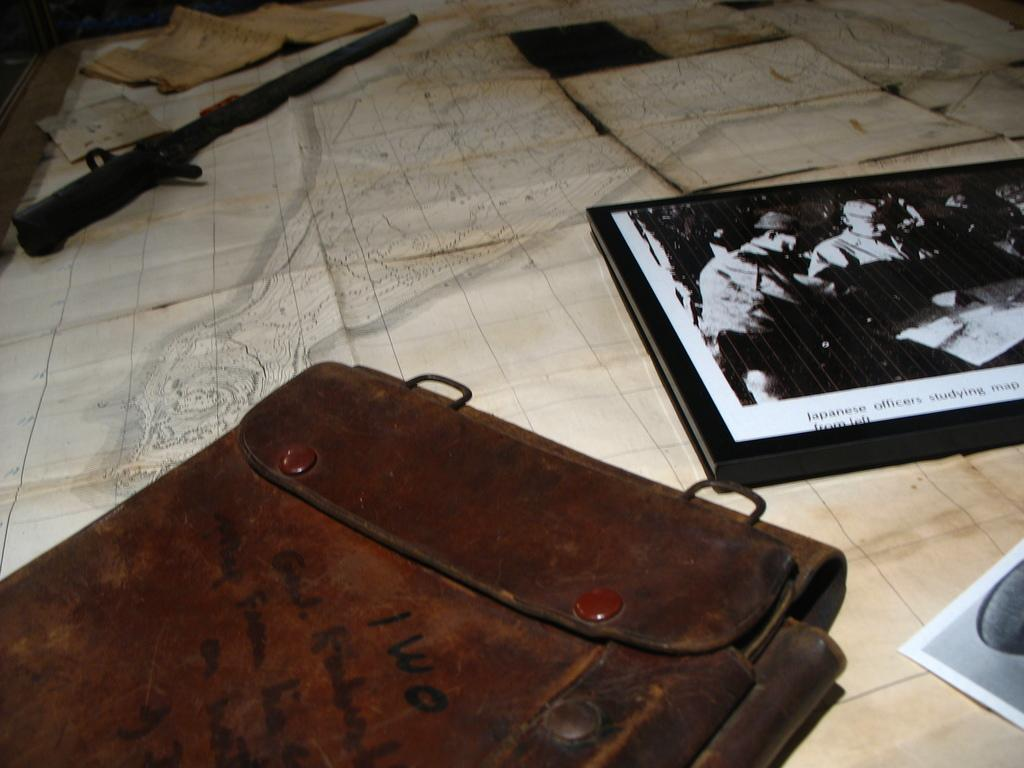What type of object can be seen in the image that might be used for carrying items? There is a bag in the image that might be used for carrying items. What type of object can be seen in the image that might be used for reading or learning? There is a book in the image that might be used for reading or learning. What type of object can be seen in the image that might be used for protection or defense? There is a gun in the image that might be used for protection or defense. What type of object can be seen in the image that might be used for writing or documentation? There are papers in the image that might be used for writing or documentation. What type of object can be seen in the image that might be used for preserving memories or displaying images? There are photos in the image that might be used for preserving memories or displaying images. On what surface are all these objects placed in the image? All of these objects are placed on a table in the image. How many rings can be seen on the table in the image? There are no rings visible on the table in the image. What type of verse is written on the back of the book in the image? There is no verse written on the back of the book in the image, as the book is not open and no text is visible. 